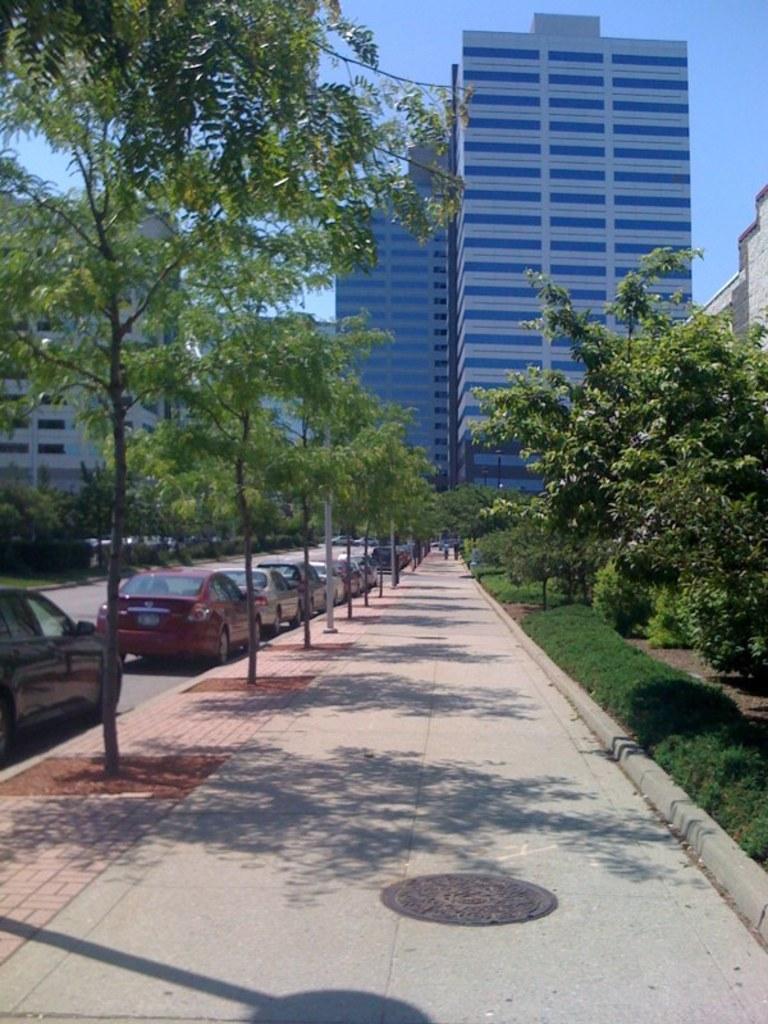Can you describe this image briefly? On the right there are trees, plants and buildings. In the center of the picture there are trees, footpath and buildings. On the left there are cars, trees and buildings. It is a sunny day. 